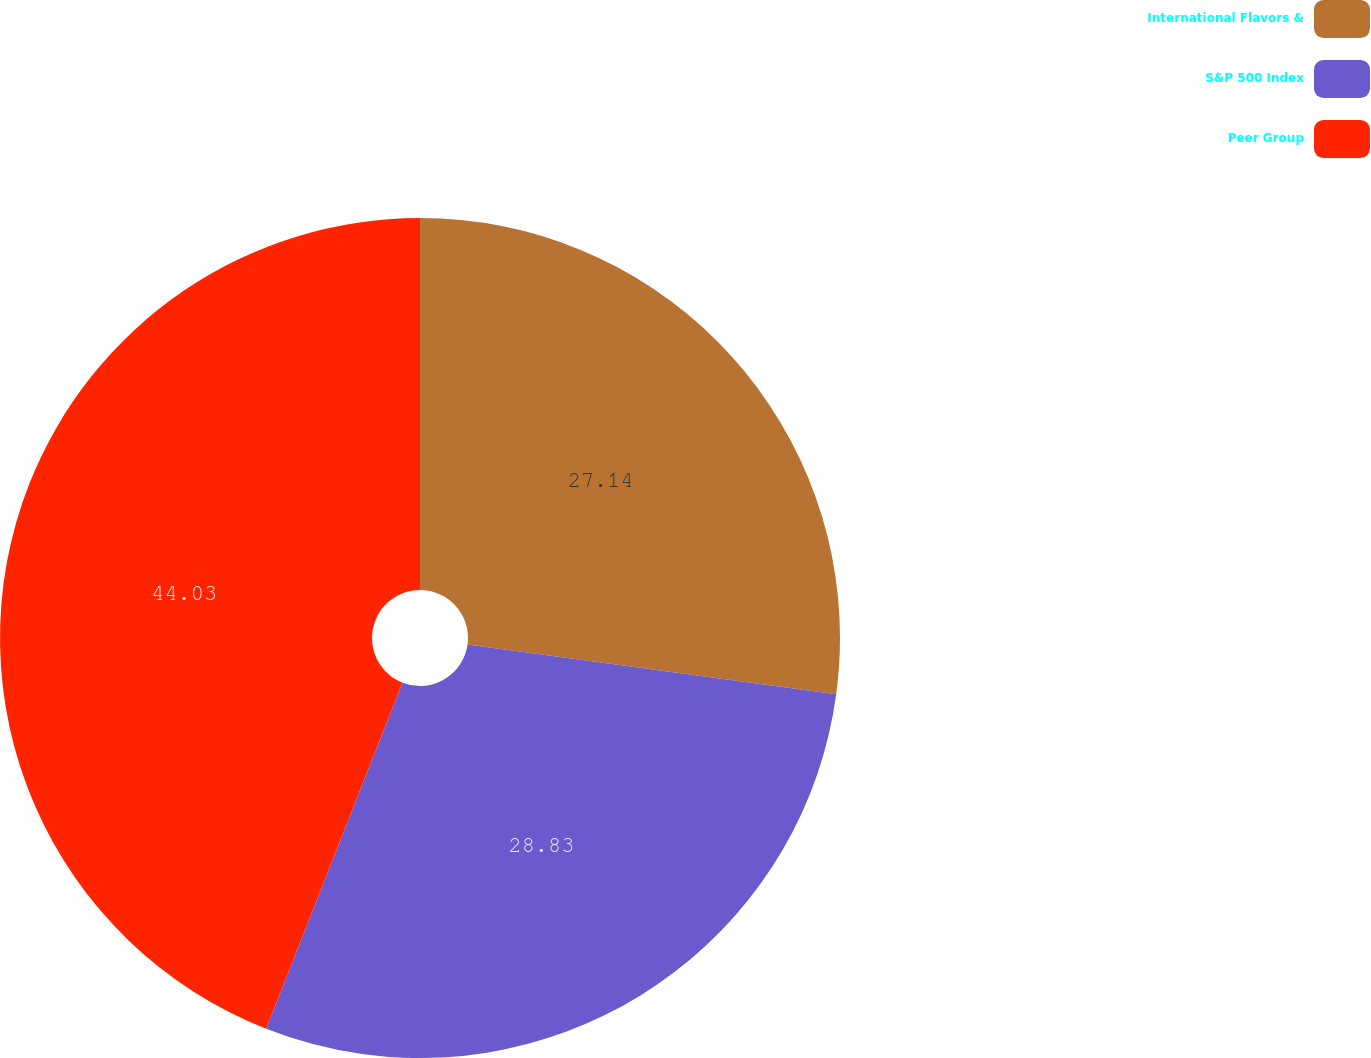Convert chart to OTSL. <chart><loc_0><loc_0><loc_500><loc_500><pie_chart><fcel>International Flavors &<fcel>S&P 500 Index<fcel>Peer Group<nl><fcel>27.14%<fcel>28.83%<fcel>44.03%<nl></chart> 